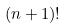<formula> <loc_0><loc_0><loc_500><loc_500>( n + 1 ) !</formula> 